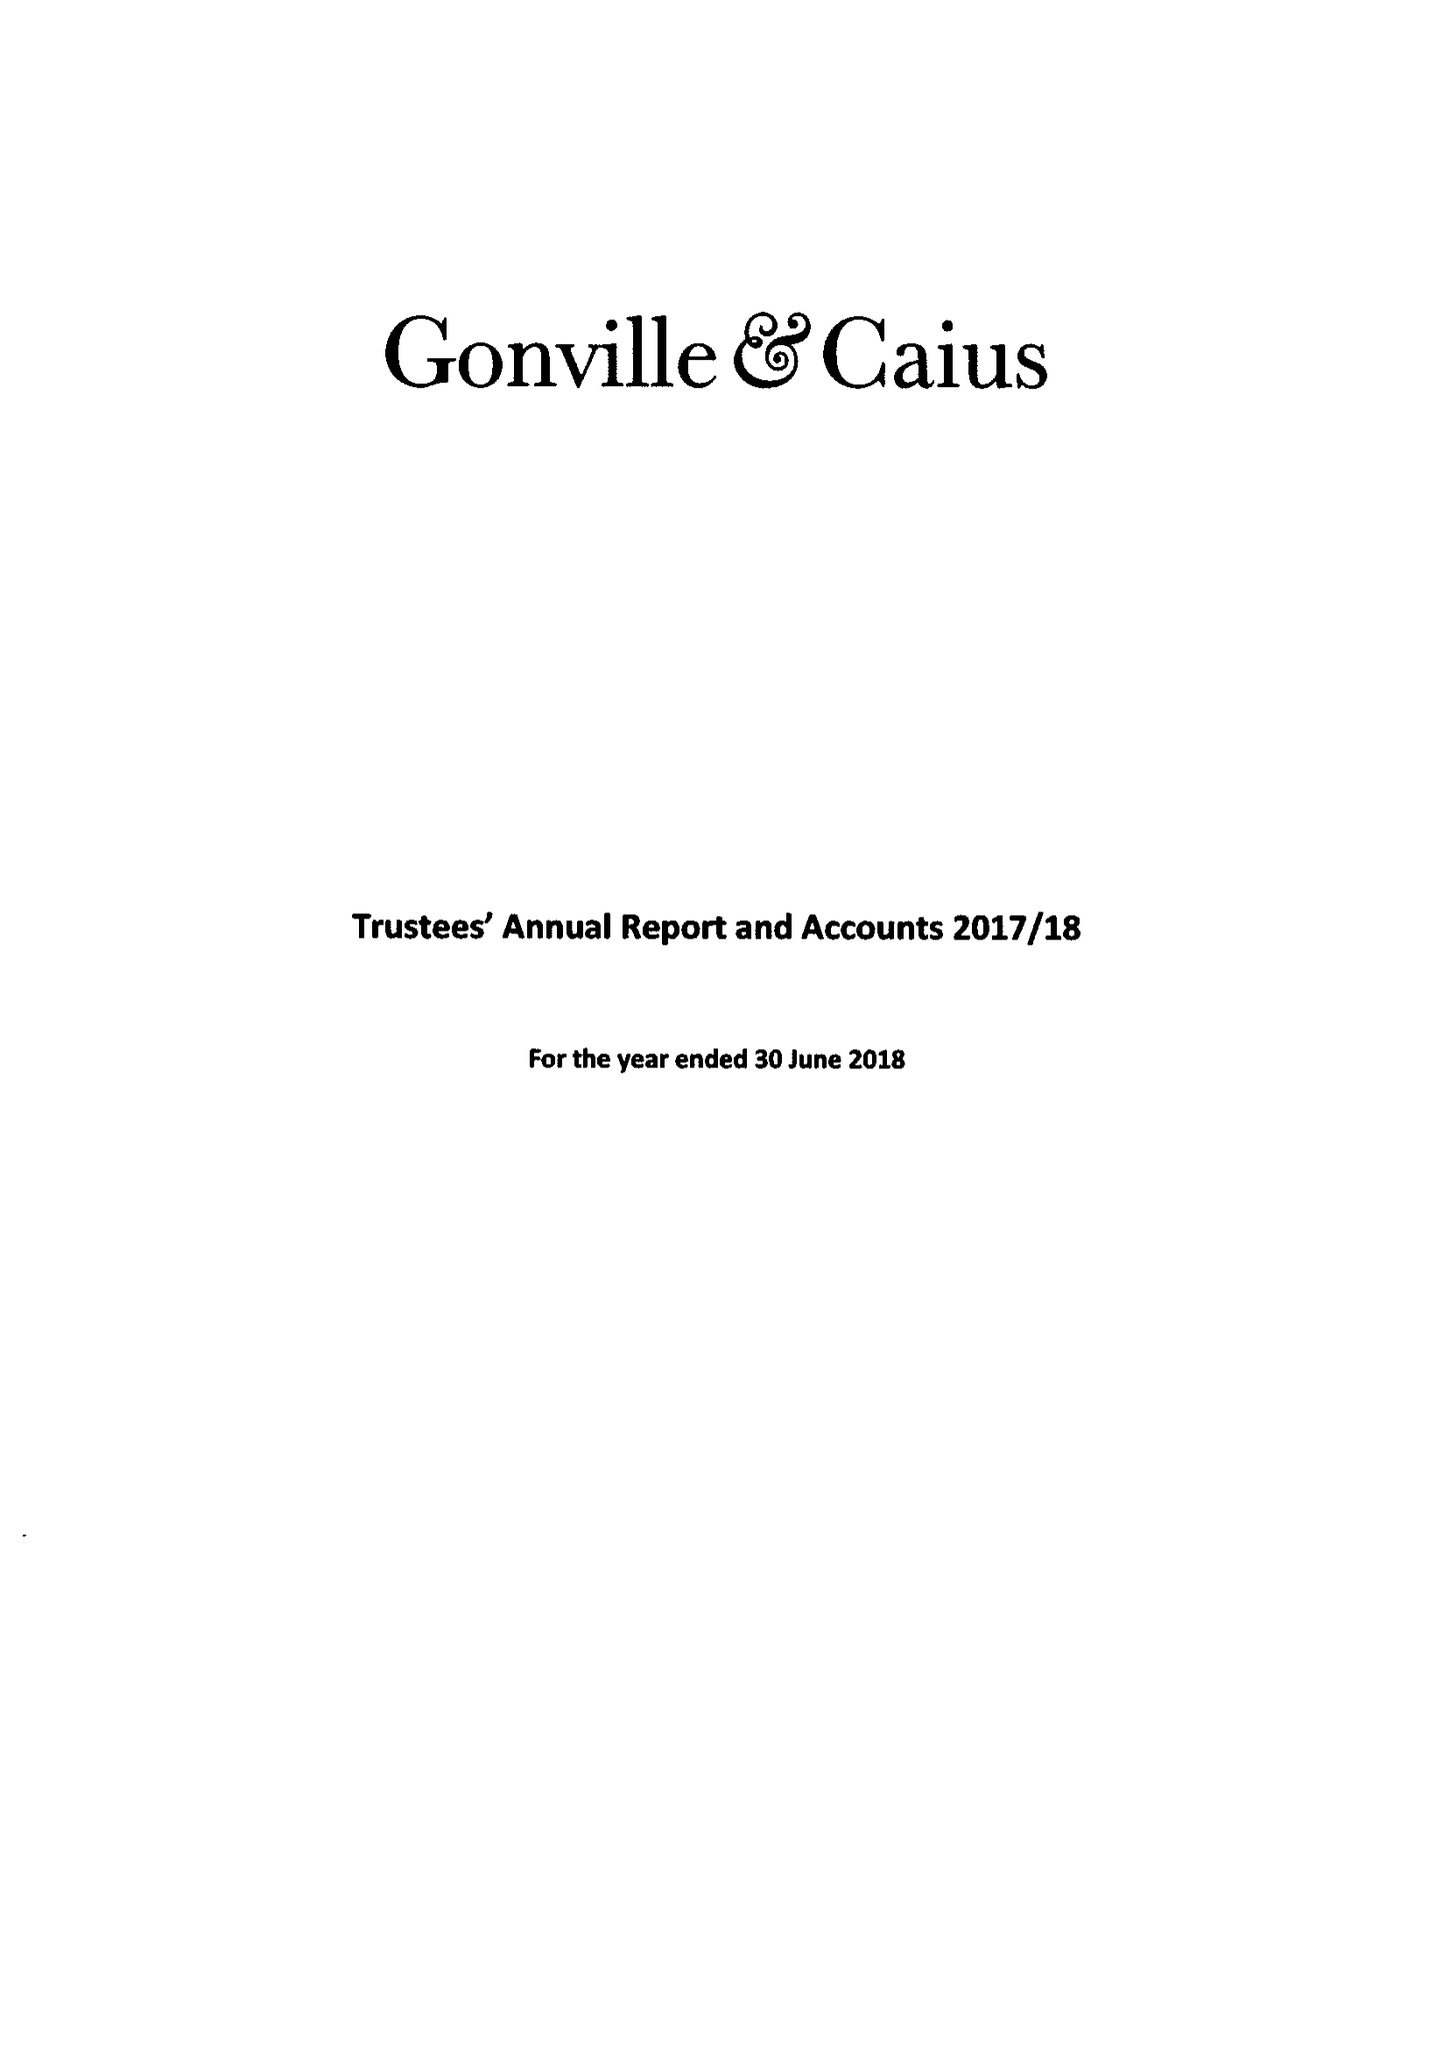What is the value for the address__street_line?
Answer the question using a single word or phrase. TRINITY STREET 